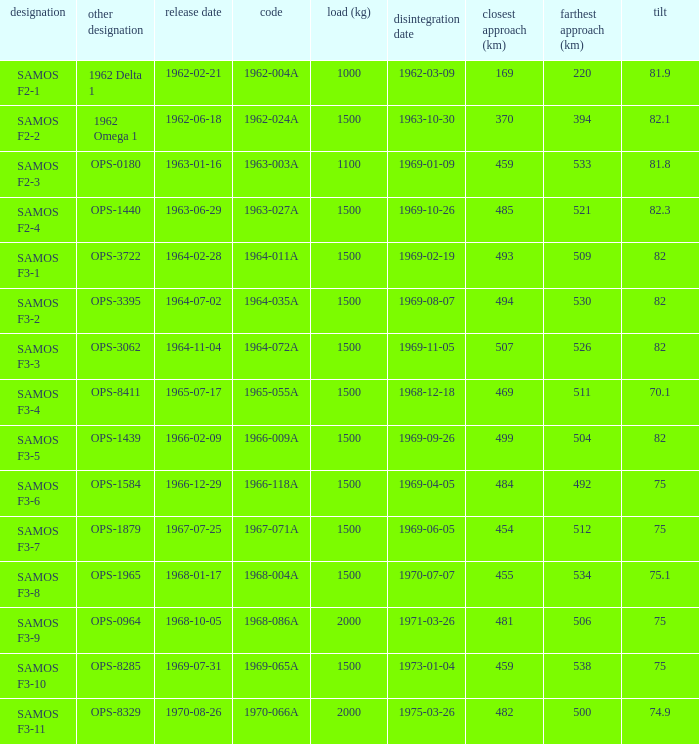How many alt names does 1964-011a have? 1.0. 